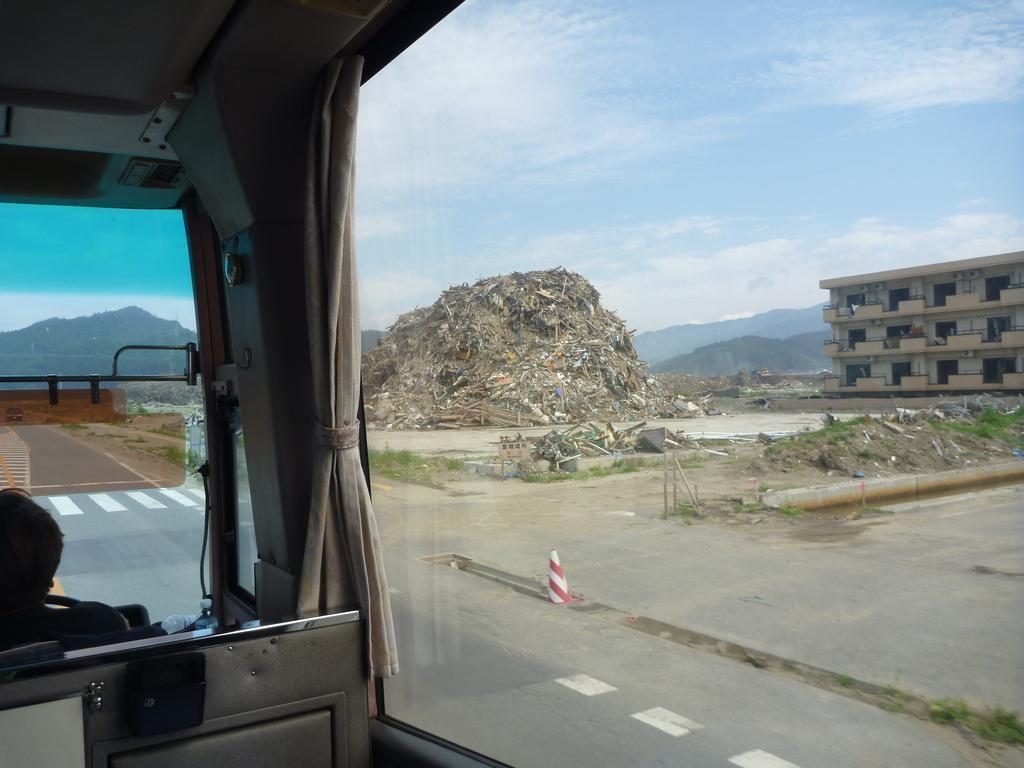In one or two sentences, can you explain what this image depicts? Here we can see a person inside a vehicle. There are glasses and a curtain. From the glass we can see road, traffic cone, trash, building, and mountain. In the background there is sky. 